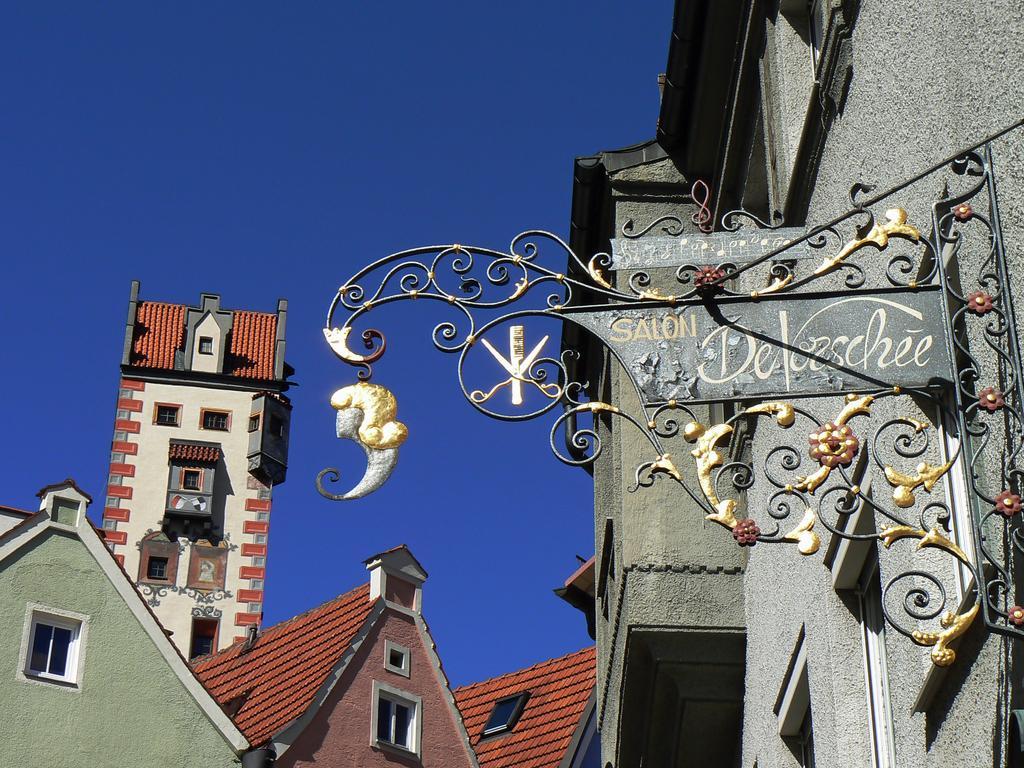Describe this image in one or two sentences. In this image there are some buildings on the right side there is a board, on the board there is text. At the top there is sky. 